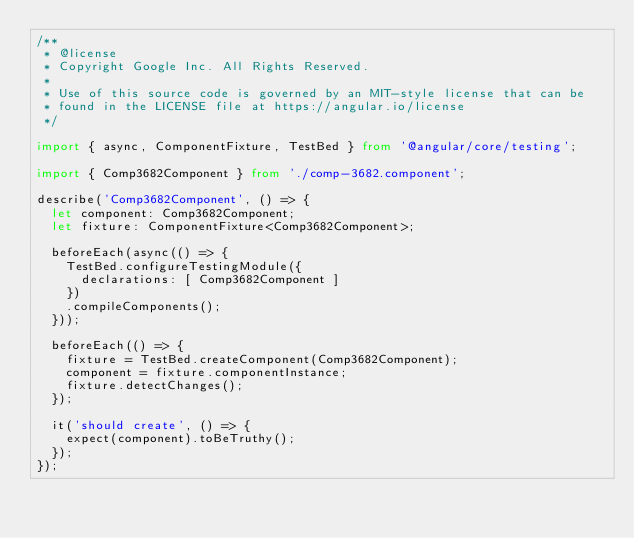<code> <loc_0><loc_0><loc_500><loc_500><_TypeScript_>/**
 * @license
 * Copyright Google Inc. All Rights Reserved.
 *
 * Use of this source code is governed by an MIT-style license that can be
 * found in the LICENSE file at https://angular.io/license
 */

import { async, ComponentFixture, TestBed } from '@angular/core/testing';

import { Comp3682Component } from './comp-3682.component';

describe('Comp3682Component', () => {
  let component: Comp3682Component;
  let fixture: ComponentFixture<Comp3682Component>;

  beforeEach(async(() => {
    TestBed.configureTestingModule({
      declarations: [ Comp3682Component ]
    })
    .compileComponents();
  }));

  beforeEach(() => {
    fixture = TestBed.createComponent(Comp3682Component);
    component = fixture.componentInstance;
    fixture.detectChanges();
  });

  it('should create', () => {
    expect(component).toBeTruthy();
  });
});
</code> 